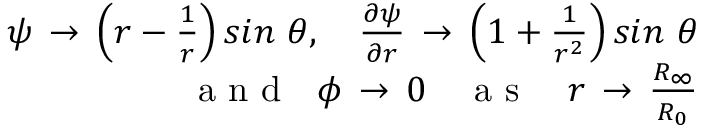<formula> <loc_0><loc_0><loc_500><loc_500>\begin{array} { r } { \psi \, \to \, \left ( r - \frac { 1 } { r } \right ) \sin \ \theta , \quad f r a c { \partial \psi } { \partial r } \, \to \, \left ( 1 + \frac { 1 } { r ^ { 2 } } \right ) \sin \ \theta } \\ { a n d \quad p h i \, \to \, 0 \quad a s \quad r \, \to \, \frac { R _ { \infty } } { R _ { 0 } } } \end{array}</formula> 